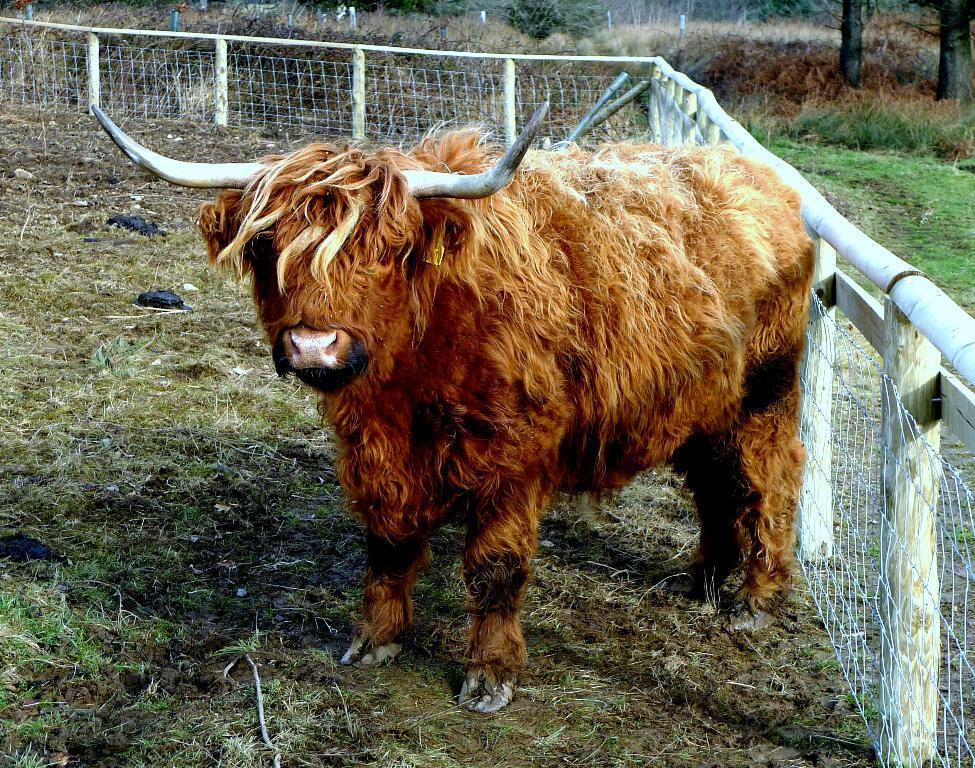What is the main subject in the center of the image? There is a yak in the center of the image. What is in front of the yak? There is a boundary in front of the yak. What type of environment surrounds the area in the image? There is grassland surrounding the area in the image. What language is the yak speaking in the image? Yaks do not speak any language, so this question cannot be answered. 